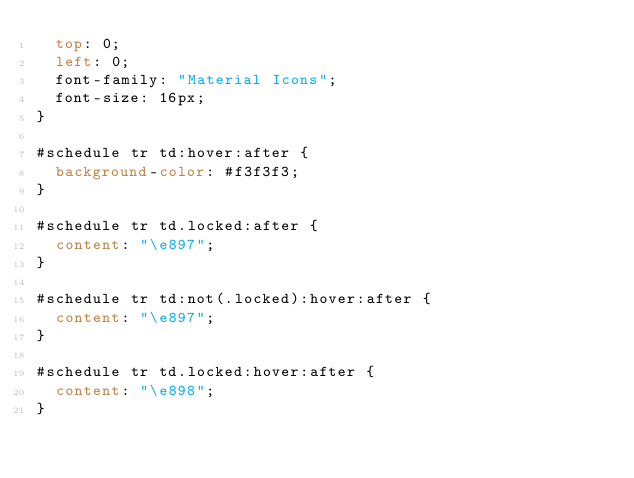<code> <loc_0><loc_0><loc_500><loc_500><_CSS_>  top: 0;
  left: 0;
  font-family: "Material Icons";
  font-size: 16px;
}

#schedule tr td:hover:after {
  background-color: #f3f3f3;
}

#schedule tr td.locked:after {
  content: "\e897";
}

#schedule tr td:not(.locked):hover:after {
  content: "\e897";
}

#schedule tr td.locked:hover:after {
  content: "\e898";
}
</code> 